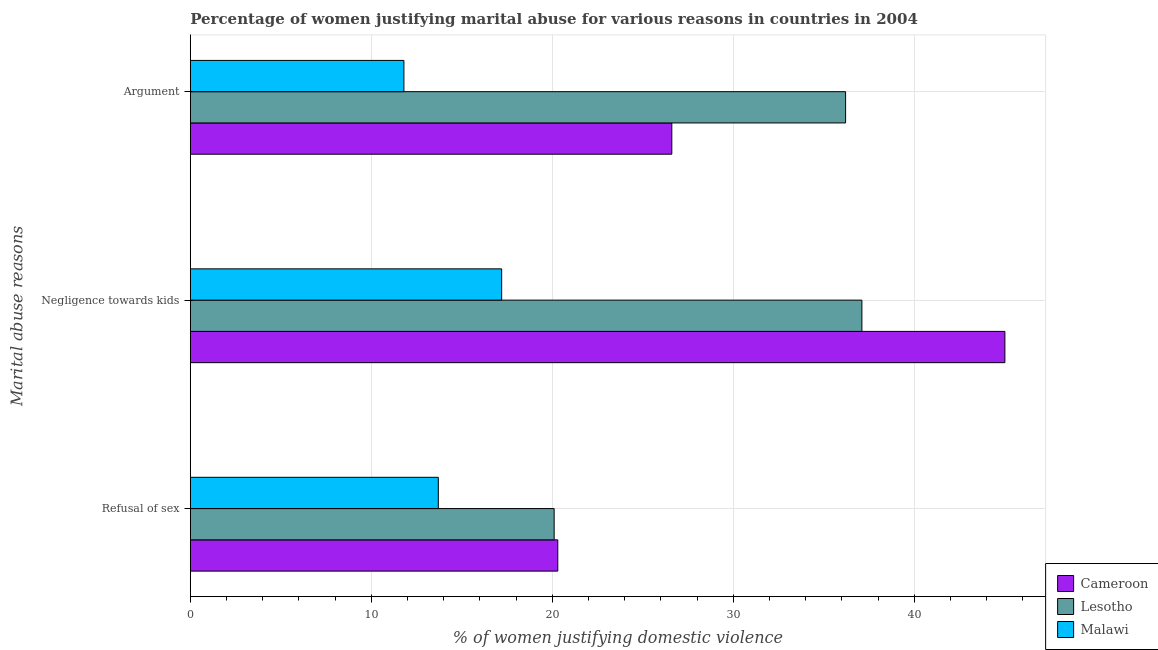How many different coloured bars are there?
Offer a very short reply. 3. What is the label of the 1st group of bars from the top?
Your response must be concise. Argument. What is the percentage of women justifying domestic violence due to arguments in Cameroon?
Offer a very short reply. 26.6. Across all countries, what is the maximum percentage of women justifying domestic violence due to arguments?
Your response must be concise. 36.2. Across all countries, what is the minimum percentage of women justifying domestic violence due to refusal of sex?
Your response must be concise. 13.7. In which country was the percentage of women justifying domestic violence due to arguments maximum?
Your response must be concise. Lesotho. In which country was the percentage of women justifying domestic violence due to negligence towards kids minimum?
Offer a very short reply. Malawi. What is the total percentage of women justifying domestic violence due to negligence towards kids in the graph?
Offer a terse response. 99.3. What is the difference between the percentage of women justifying domestic violence due to refusal of sex in Cameroon and that in Lesotho?
Make the answer very short. 0.2. What is the difference between the percentage of women justifying domestic violence due to negligence towards kids in Lesotho and the percentage of women justifying domestic violence due to arguments in Malawi?
Give a very brief answer. 25.3. What is the average percentage of women justifying domestic violence due to arguments per country?
Offer a very short reply. 24.87. In how many countries, is the percentage of women justifying domestic violence due to refusal of sex greater than 32 %?
Your answer should be compact. 0. What is the ratio of the percentage of women justifying domestic violence due to arguments in Lesotho to that in Cameroon?
Make the answer very short. 1.36. Is the percentage of women justifying domestic violence due to refusal of sex in Lesotho less than that in Cameroon?
Give a very brief answer. Yes. What is the difference between the highest and the second highest percentage of women justifying domestic violence due to negligence towards kids?
Keep it short and to the point. 7.9. What is the difference between the highest and the lowest percentage of women justifying domestic violence due to negligence towards kids?
Your answer should be very brief. 27.8. In how many countries, is the percentage of women justifying domestic violence due to negligence towards kids greater than the average percentage of women justifying domestic violence due to negligence towards kids taken over all countries?
Provide a short and direct response. 2. Is the sum of the percentage of women justifying domestic violence due to negligence towards kids in Lesotho and Malawi greater than the maximum percentage of women justifying domestic violence due to refusal of sex across all countries?
Provide a succinct answer. Yes. What does the 1st bar from the top in Refusal of sex represents?
Make the answer very short. Malawi. What does the 1st bar from the bottom in Argument represents?
Ensure brevity in your answer.  Cameroon. Is it the case that in every country, the sum of the percentage of women justifying domestic violence due to refusal of sex and percentage of women justifying domestic violence due to negligence towards kids is greater than the percentage of women justifying domestic violence due to arguments?
Keep it short and to the point. Yes. Are the values on the major ticks of X-axis written in scientific E-notation?
Offer a terse response. No. Does the graph contain any zero values?
Keep it short and to the point. No. Does the graph contain grids?
Ensure brevity in your answer.  Yes. Where does the legend appear in the graph?
Keep it short and to the point. Bottom right. How many legend labels are there?
Offer a very short reply. 3. What is the title of the graph?
Your response must be concise. Percentage of women justifying marital abuse for various reasons in countries in 2004. What is the label or title of the X-axis?
Your response must be concise. % of women justifying domestic violence. What is the label or title of the Y-axis?
Offer a very short reply. Marital abuse reasons. What is the % of women justifying domestic violence of Cameroon in Refusal of sex?
Ensure brevity in your answer.  20.3. What is the % of women justifying domestic violence in Lesotho in Refusal of sex?
Offer a terse response. 20.1. What is the % of women justifying domestic violence of Lesotho in Negligence towards kids?
Your response must be concise. 37.1. What is the % of women justifying domestic violence in Cameroon in Argument?
Give a very brief answer. 26.6. What is the % of women justifying domestic violence of Lesotho in Argument?
Offer a very short reply. 36.2. Across all Marital abuse reasons, what is the maximum % of women justifying domestic violence in Lesotho?
Ensure brevity in your answer.  37.1. Across all Marital abuse reasons, what is the minimum % of women justifying domestic violence of Cameroon?
Ensure brevity in your answer.  20.3. Across all Marital abuse reasons, what is the minimum % of women justifying domestic violence in Lesotho?
Offer a terse response. 20.1. What is the total % of women justifying domestic violence of Cameroon in the graph?
Ensure brevity in your answer.  91.9. What is the total % of women justifying domestic violence in Lesotho in the graph?
Provide a short and direct response. 93.4. What is the total % of women justifying domestic violence in Malawi in the graph?
Your response must be concise. 42.7. What is the difference between the % of women justifying domestic violence of Cameroon in Refusal of sex and that in Negligence towards kids?
Ensure brevity in your answer.  -24.7. What is the difference between the % of women justifying domestic violence of Malawi in Refusal of sex and that in Negligence towards kids?
Your answer should be very brief. -3.5. What is the difference between the % of women justifying domestic violence in Lesotho in Refusal of sex and that in Argument?
Provide a short and direct response. -16.1. What is the difference between the % of women justifying domestic violence in Cameroon in Refusal of sex and the % of women justifying domestic violence in Lesotho in Negligence towards kids?
Your answer should be very brief. -16.8. What is the difference between the % of women justifying domestic violence in Cameroon in Refusal of sex and the % of women justifying domestic violence in Lesotho in Argument?
Offer a terse response. -15.9. What is the difference between the % of women justifying domestic violence in Cameroon in Refusal of sex and the % of women justifying domestic violence in Malawi in Argument?
Keep it short and to the point. 8.5. What is the difference between the % of women justifying domestic violence of Lesotho in Refusal of sex and the % of women justifying domestic violence of Malawi in Argument?
Your answer should be very brief. 8.3. What is the difference between the % of women justifying domestic violence of Cameroon in Negligence towards kids and the % of women justifying domestic violence of Lesotho in Argument?
Ensure brevity in your answer.  8.8. What is the difference between the % of women justifying domestic violence in Cameroon in Negligence towards kids and the % of women justifying domestic violence in Malawi in Argument?
Ensure brevity in your answer.  33.2. What is the difference between the % of women justifying domestic violence of Lesotho in Negligence towards kids and the % of women justifying domestic violence of Malawi in Argument?
Keep it short and to the point. 25.3. What is the average % of women justifying domestic violence of Cameroon per Marital abuse reasons?
Your answer should be very brief. 30.63. What is the average % of women justifying domestic violence of Lesotho per Marital abuse reasons?
Your response must be concise. 31.13. What is the average % of women justifying domestic violence in Malawi per Marital abuse reasons?
Provide a succinct answer. 14.23. What is the difference between the % of women justifying domestic violence in Cameroon and % of women justifying domestic violence in Lesotho in Refusal of sex?
Make the answer very short. 0.2. What is the difference between the % of women justifying domestic violence in Cameroon and % of women justifying domestic violence in Malawi in Negligence towards kids?
Provide a succinct answer. 27.8. What is the difference between the % of women justifying domestic violence in Lesotho and % of women justifying domestic violence in Malawi in Negligence towards kids?
Make the answer very short. 19.9. What is the difference between the % of women justifying domestic violence of Lesotho and % of women justifying domestic violence of Malawi in Argument?
Make the answer very short. 24.4. What is the ratio of the % of women justifying domestic violence in Cameroon in Refusal of sex to that in Negligence towards kids?
Keep it short and to the point. 0.45. What is the ratio of the % of women justifying domestic violence of Lesotho in Refusal of sex to that in Negligence towards kids?
Offer a very short reply. 0.54. What is the ratio of the % of women justifying domestic violence in Malawi in Refusal of sex to that in Negligence towards kids?
Provide a short and direct response. 0.8. What is the ratio of the % of women justifying domestic violence of Cameroon in Refusal of sex to that in Argument?
Make the answer very short. 0.76. What is the ratio of the % of women justifying domestic violence in Lesotho in Refusal of sex to that in Argument?
Provide a short and direct response. 0.56. What is the ratio of the % of women justifying domestic violence of Malawi in Refusal of sex to that in Argument?
Your answer should be compact. 1.16. What is the ratio of the % of women justifying domestic violence of Cameroon in Negligence towards kids to that in Argument?
Offer a terse response. 1.69. What is the ratio of the % of women justifying domestic violence of Lesotho in Negligence towards kids to that in Argument?
Ensure brevity in your answer.  1.02. What is the ratio of the % of women justifying domestic violence of Malawi in Negligence towards kids to that in Argument?
Your response must be concise. 1.46. What is the difference between the highest and the second highest % of women justifying domestic violence in Malawi?
Ensure brevity in your answer.  3.5. What is the difference between the highest and the lowest % of women justifying domestic violence in Cameroon?
Make the answer very short. 24.7. 